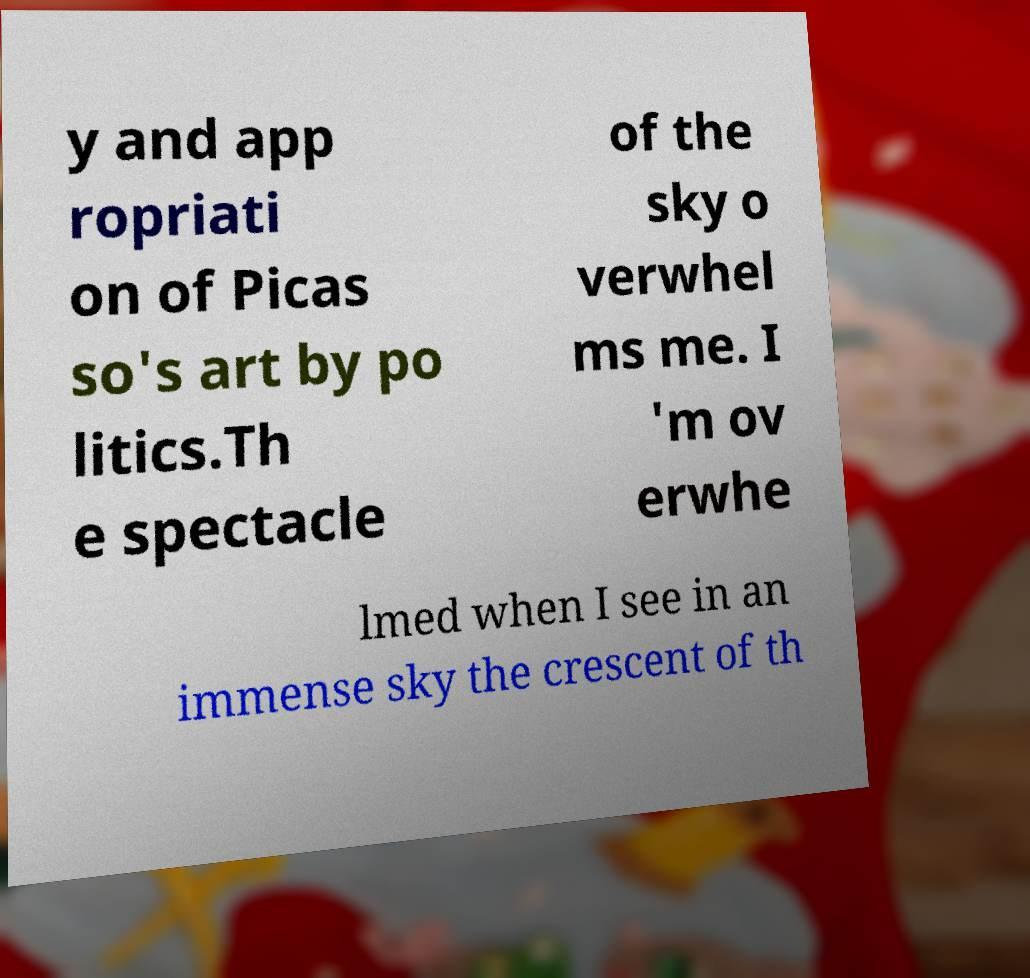For documentation purposes, I need the text within this image transcribed. Could you provide that? y and app ropriati on of Picas so's art by po litics.Th e spectacle of the sky o verwhel ms me. I 'm ov erwhe lmed when I see in an immense sky the crescent of th 